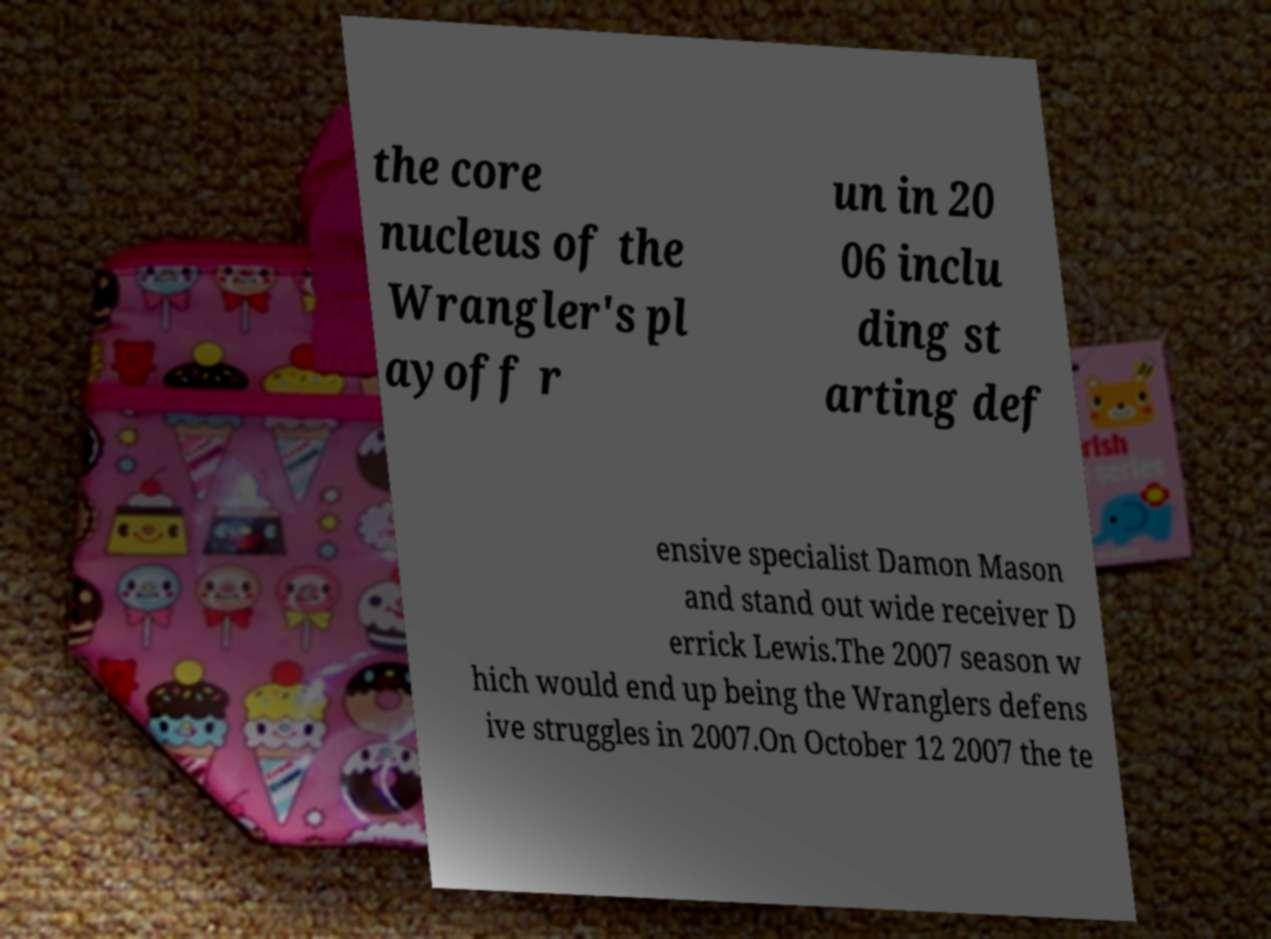Can you accurately transcribe the text from the provided image for me? the core nucleus of the Wrangler's pl ayoff r un in 20 06 inclu ding st arting def ensive specialist Damon Mason and stand out wide receiver D errick Lewis.The 2007 season w hich would end up being the Wranglers defens ive struggles in 2007.On October 12 2007 the te 